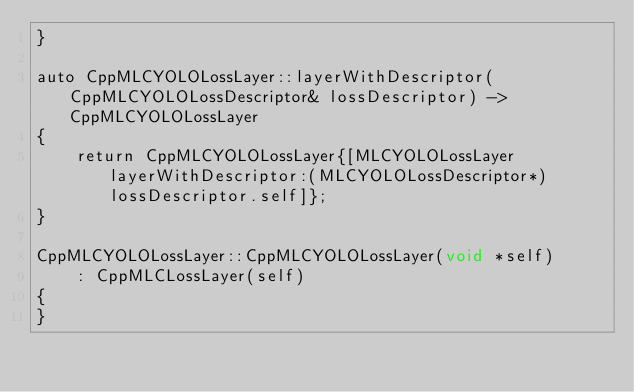Convert code to text. <code><loc_0><loc_0><loc_500><loc_500><_ObjectiveC_>}

auto CppMLCYOLOLossLayer::layerWithDescriptor(CppMLCYOLOLossDescriptor& lossDescriptor) -> CppMLCYOLOLossLayer
{
    return CppMLCYOLOLossLayer{[MLCYOLOLossLayer layerWithDescriptor:(MLCYOLOLossDescriptor*)lossDescriptor.self]};
}

CppMLCYOLOLossLayer::CppMLCYOLOLossLayer(void *self)
    : CppMLCLossLayer(self)
{
}
</code> 